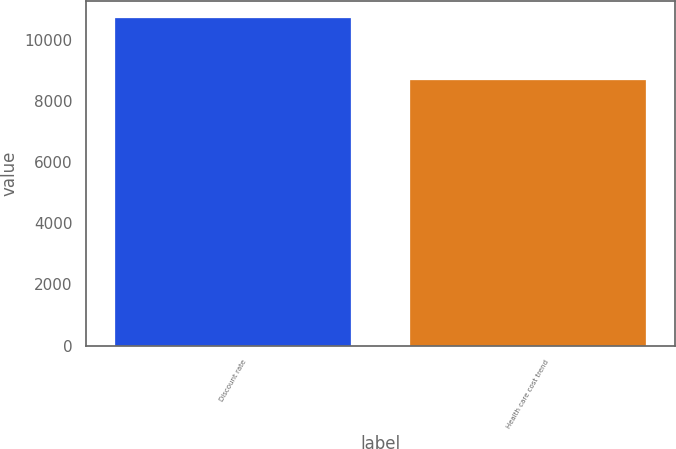<chart> <loc_0><loc_0><loc_500><loc_500><bar_chart><fcel>Discount rate<fcel>Health care cost trend<nl><fcel>10727<fcel>8675<nl></chart> 